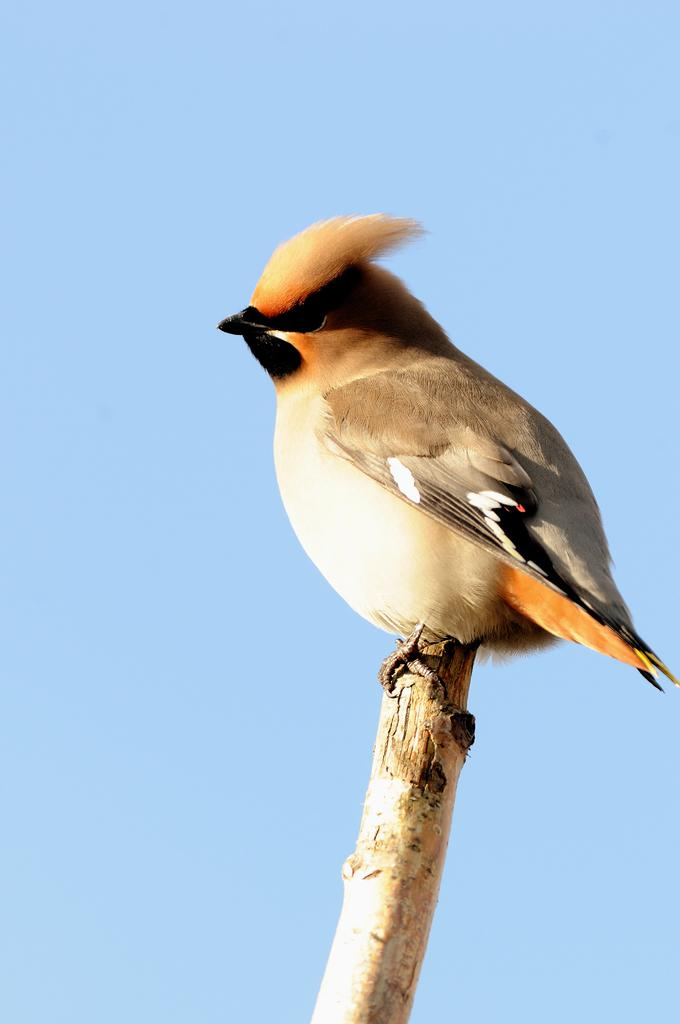What type of animal can be seen in the image? There is a bird in the image. What is the bird standing on? The bird is standing on a wooden object. What can be seen in the background of the image? The sky is visible in the background of the image. What type of cart is the bird pulling in the image? There is no cart present in the image; the bird is standing on a wooden object. How many feathers can be seen on the bird in the image? The number of feathers on the bird cannot be determined from the image, as the bird's feathers are not clearly visible. 